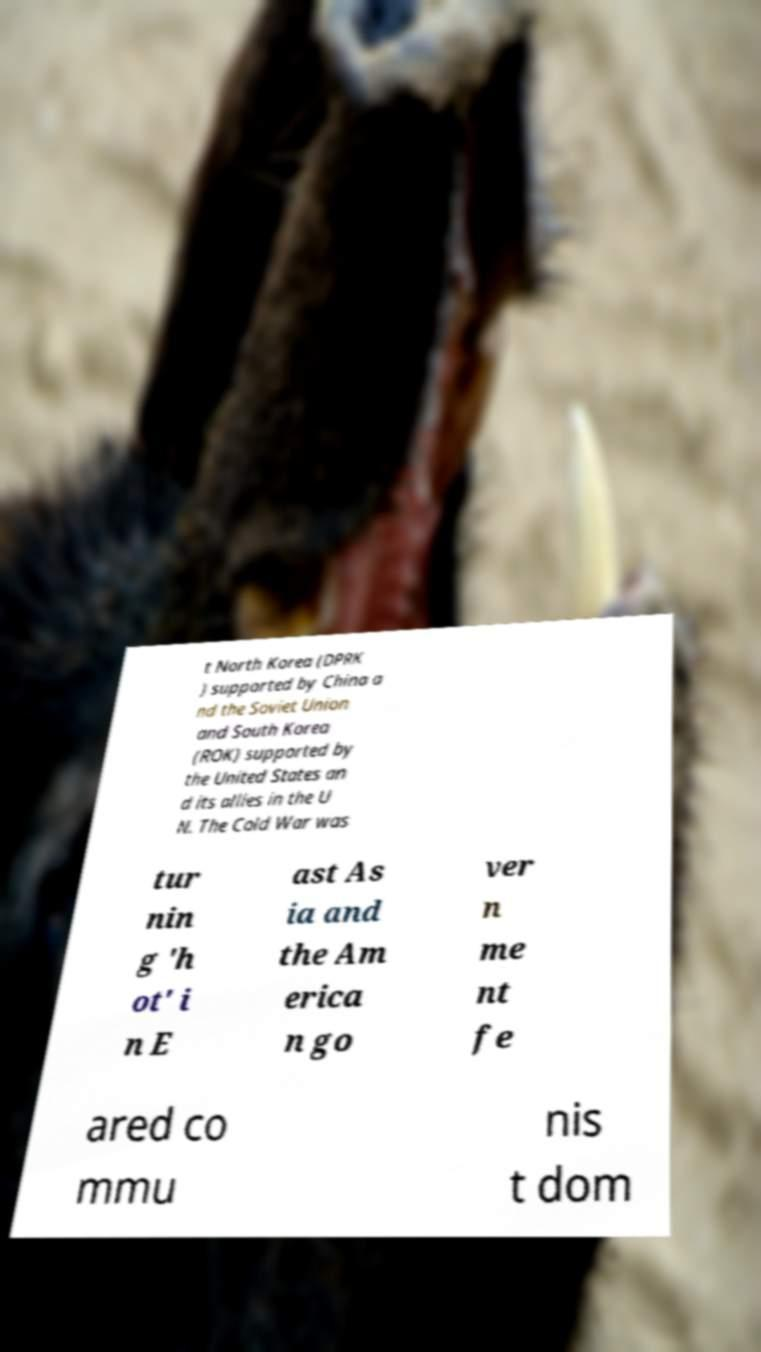For documentation purposes, I need the text within this image transcribed. Could you provide that? t North Korea (DPRK ) supported by China a nd the Soviet Union and South Korea (ROK) supported by the United States an d its allies in the U N. The Cold War was tur nin g 'h ot' i n E ast As ia and the Am erica n go ver n me nt fe ared co mmu nis t dom 